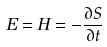Convert formula to latex. <formula><loc_0><loc_0><loc_500><loc_500>E = H = - \frac { \partial S } { \partial t }</formula> 